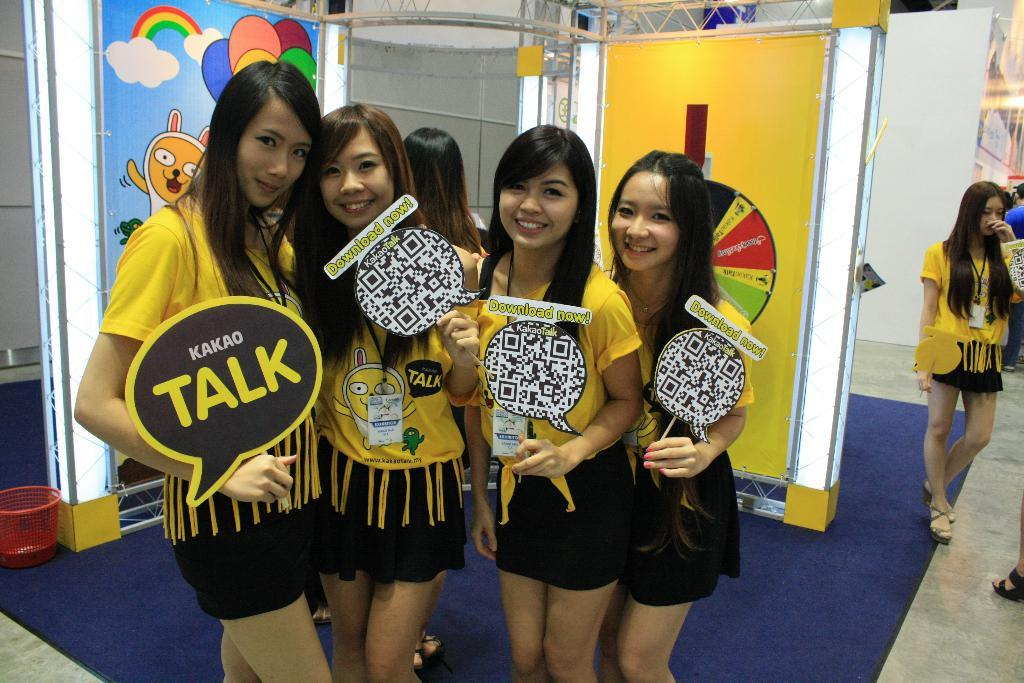<image>
Describe the image concisely. Several models persuading people to download the Kakao talk app. 